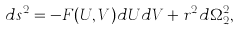<formula> <loc_0><loc_0><loc_500><loc_500>d s ^ { 2 } = - F ( U , V ) d U d V + r ^ { 2 } d \Omega _ { 2 } ^ { 2 } ,</formula> 